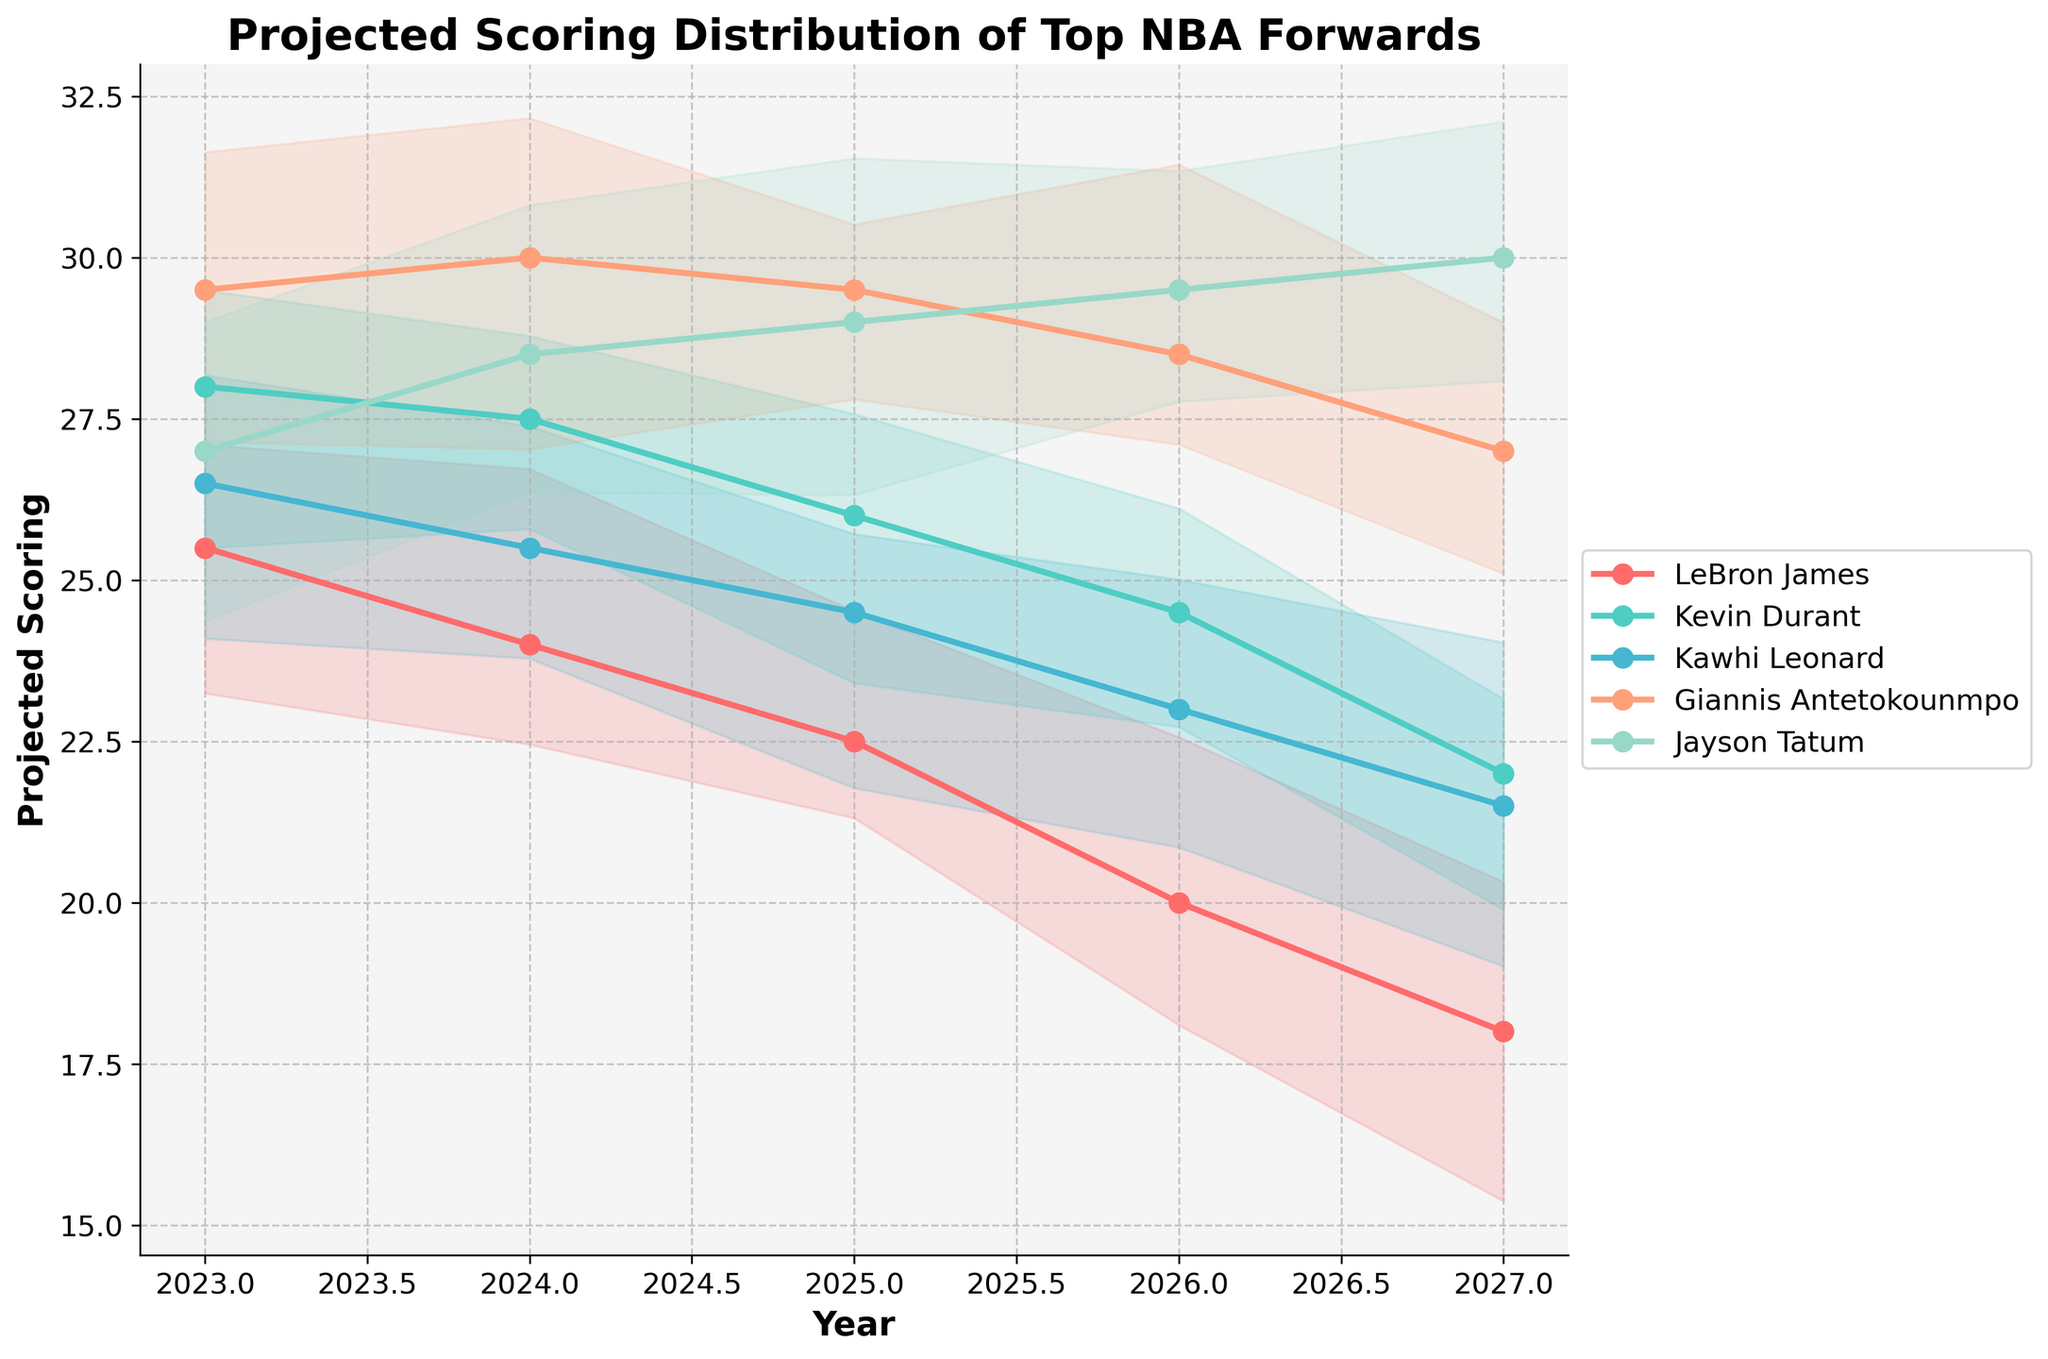What is the title of the chart? The title of the chart is typically located at the top of the figure. It provides an overall description of what the chart is about.
Answer: Projected Scoring Distribution of Top NBA Forwards Which player is projected to have the highest scoring in 2027? To answer this, observe the lines or markers representing scoring for the year 2027 and identify the player whose scoring is highest.
Answer: Jayson Tatum What is the trend of LeBron James' projected scoring over the next 5 years? Track LeBron James' line across the years from 2023 to 2027. Notice the general direction of his scoring over time.
Answer: Decreasing How does Giannis Antetokounmpo's projected scoring in 2025 compare to Kevin Durant's scoring in the same year? Locate both players' markers for the year 2025 and compare their values to determine which is higher or if they are equal.
Answer: Giannis Antetokounmpo's scoring is higher What are the upper and lower bounds of Kevin Durant's projected scoring in 2024? Identify Kevin Durant's line for 2024, then locate the shaded area around it, and read off the upper and lower bounds of the scoring.
Answer: Upper: ~30.5, Lower: ~24.5 Which player's scoring shows the most consistent decline over the 5-year period? Look at the lines for each player and see which one shows a steady decrease without fluctuations up and down over time.
Answer: LeBron James In 2026, how much higher is Jayson Tatum's projected scoring compared to Kawhi Leonard's? Find both players' projected scores for 2026 and calculate the difference between Tatum's and Leonard's scores.
Answer: 6.5 points Which player shows an increase in projected scoring from 2023 to 2024? Find each player's scores for 2023 and 2024 and determine which player's score is higher in 2024 compared to 2023.
Answer: Jayson Tatum What is the average projected scoring for Kawhi Leonard over the next 5 years? Add Kawhi Leonard's scores from 2023 to 2027 and divide by 5 to find the average.
Answer: 24.2 points Which players' projected scoring are shown with the red shade? Identify the colors used for each player's line, noting which one corresponds to the red shade.
Answer: LeBron James 